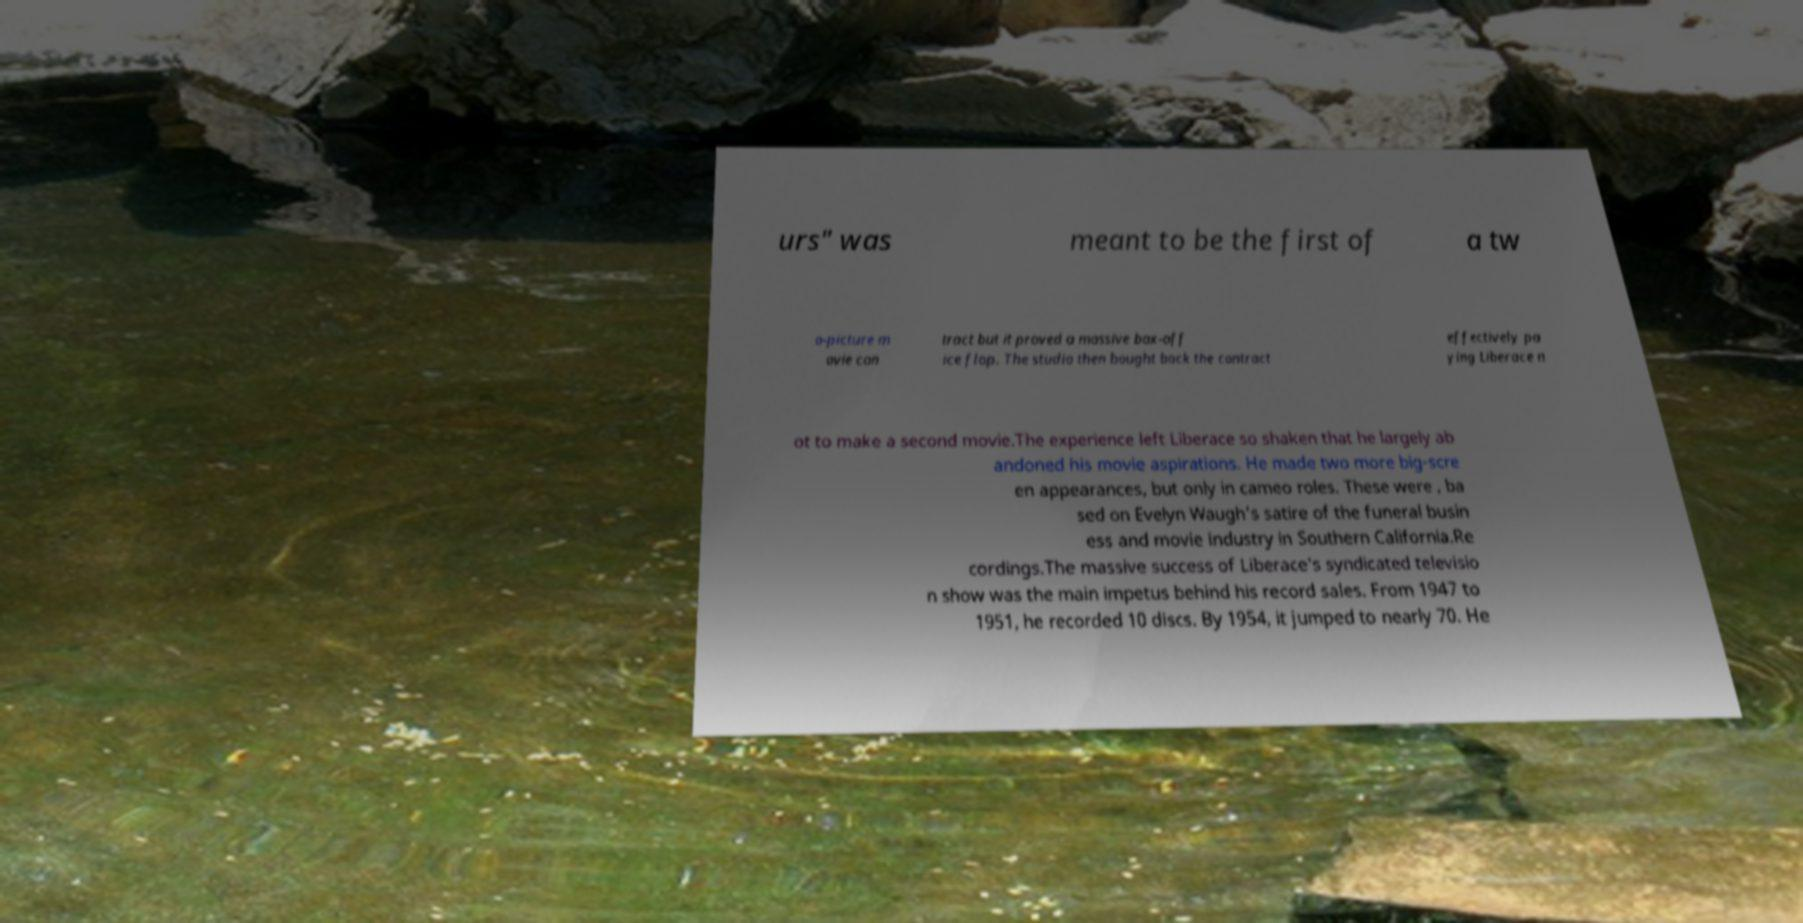Please read and relay the text visible in this image. What does it say? urs" was meant to be the first of a tw o-picture m ovie con tract but it proved a massive box-off ice flop. The studio then bought back the contract effectively pa ying Liberace n ot to make a second movie.The experience left Liberace so shaken that he largely ab andoned his movie aspirations. He made two more big-scre en appearances, but only in cameo roles. These were , ba sed on Evelyn Waugh's satire of the funeral busin ess and movie industry in Southern California.Re cordings.The massive success of Liberace's syndicated televisio n show was the main impetus behind his record sales. From 1947 to 1951, he recorded 10 discs. By 1954, it jumped to nearly 70. He 